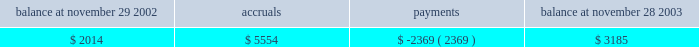Guarantees we adopted fasb interpretation no .
45 ( 201cfin 45 201d ) , 201cguarantor 2019s accounting and disclosure requirements for guarantees , including indirect guarantees of indebtedness of others 201d at the beginning of our fiscal 2003 .
See 201crecent accounting pronouncements 201d for further information regarding fin 45 .
The lease agreements for our three office buildings in san jose , california provide for residual value guarantees .
These lease agreements were in place prior to december 31 , 2002 and are disclosed in note 14 .
In the normal course of business , we provide indemnifications of varying scope to customers against claims of intellectual property infringement made by third parties arising from the use of our products .
Historically , costs related to these indemnification provisions have not been significant and we are unable to estimate the maximum potential impact of these indemnification provisions on our future results of operations .
We have commitments to make certain milestone and/or retention payments typically entered into in conjunction with various acquisitions , for which we have made accruals in our consolidated financial statements .
In connection with our purchases of technology assets during fiscal 2003 , we entered into employee retention agreements totaling $ 2.2 million .
We are required to make payments upon satisfaction of certain conditions in the agreements .
As permitted under delaware law , we have agreements whereby we indemnify our officers and directors for certain events or occurrences while the officer or director is , or was serving , at our request in such capacity .
The indemnification period covers all pertinent events and occurrences during the officer 2019s or director 2019s lifetime .
The maximum potential amount of future payments we could be required to make under these indemnification agreements is unlimited ; however , we have director and officer insurance coverage that limits our exposure and enables us to recover a portion of any future amounts paid .
We believe the estimated fair value of these indemnification agreements in excess of applicable insurance coverage is minimal .
As part of our limited partnership interests in adobe ventures , we have provided a general indemnification to granite ventures , an independent venture capital firm and sole general partner of adobe ventures , for certain events or occurrences while granite ventures is , or was serving , at our request in such capacity provided that granite ventures acts in good faith on behalf of the partnerships .
We are unable to develop an estimate of the maximum potential amount of future payments that could potentially result from any hypothetical future claim , but believe the risk of having to make any payments under this general indemnification to be remote .
We accrue for costs associated with future obligations which include costs for undetected bugs that are discovered only after the product is installed and used by customers .
The accrual remaining at the end of fiscal 2003 primarily relates to new releases of our creative suites products during the fourth quarter of fiscal 2003 .
The table below summarizes the activity related to the accrual during fiscal 2003 : balance at november 29 , 2002 accruals payments balance at november 28 , 2003 .
Advertising expenses we expense all advertising costs as incurred and classify these costs under sales and marketing expense .
Advertising expenses for fiscal years 2003 , 2002 , and 2001 were $ 24.0 million , $ 26.7 million and $ 30.5 million , respectively .
Foreign currency and other hedging instruments statement of financial accounting standards no .
133 ( 201csfas no .
133 201d ) , 201caccounting for derivative instruments and hedging activities , 201d establishes accounting and reporting standards for derivative instruments and hedging activities and requires us to recognize these as either assets or liabilities on the balance sheet and measure them at fair value .
As described in note 15 , gains and losses resulting from .
What is the growth rate in advertising expense in 2003 relative to 2002? 
Computations: ((24.0 - 26.7) / 26.7)
Answer: -0.10112. 